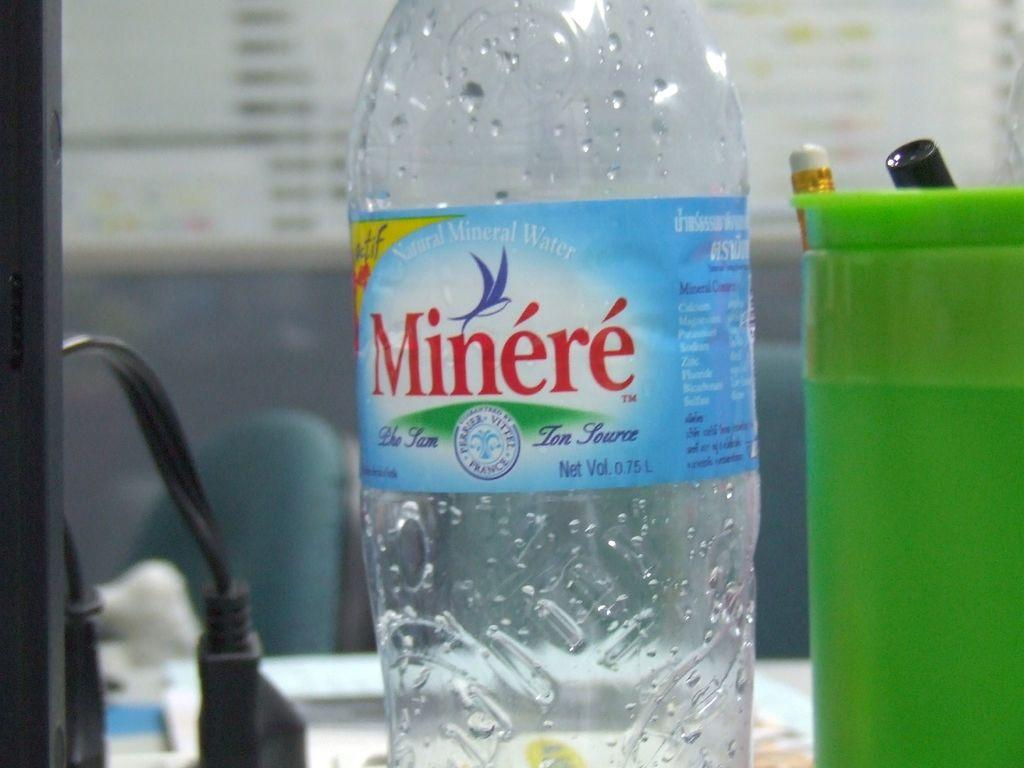Provide a one-sentence caption for the provided image. an empty water bottle with the Minere brand on it. 